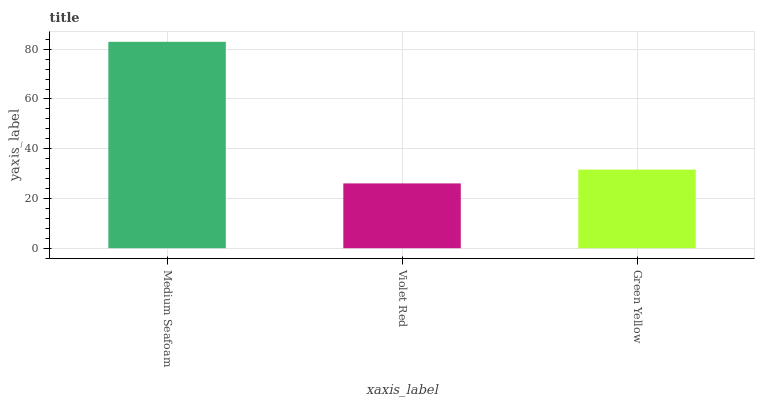Is Violet Red the minimum?
Answer yes or no. Yes. Is Medium Seafoam the maximum?
Answer yes or no. Yes. Is Green Yellow the minimum?
Answer yes or no. No. Is Green Yellow the maximum?
Answer yes or no. No. Is Green Yellow greater than Violet Red?
Answer yes or no. Yes. Is Violet Red less than Green Yellow?
Answer yes or no. Yes. Is Violet Red greater than Green Yellow?
Answer yes or no. No. Is Green Yellow less than Violet Red?
Answer yes or no. No. Is Green Yellow the high median?
Answer yes or no. Yes. Is Green Yellow the low median?
Answer yes or no. Yes. Is Medium Seafoam the high median?
Answer yes or no. No. Is Violet Red the low median?
Answer yes or no. No. 